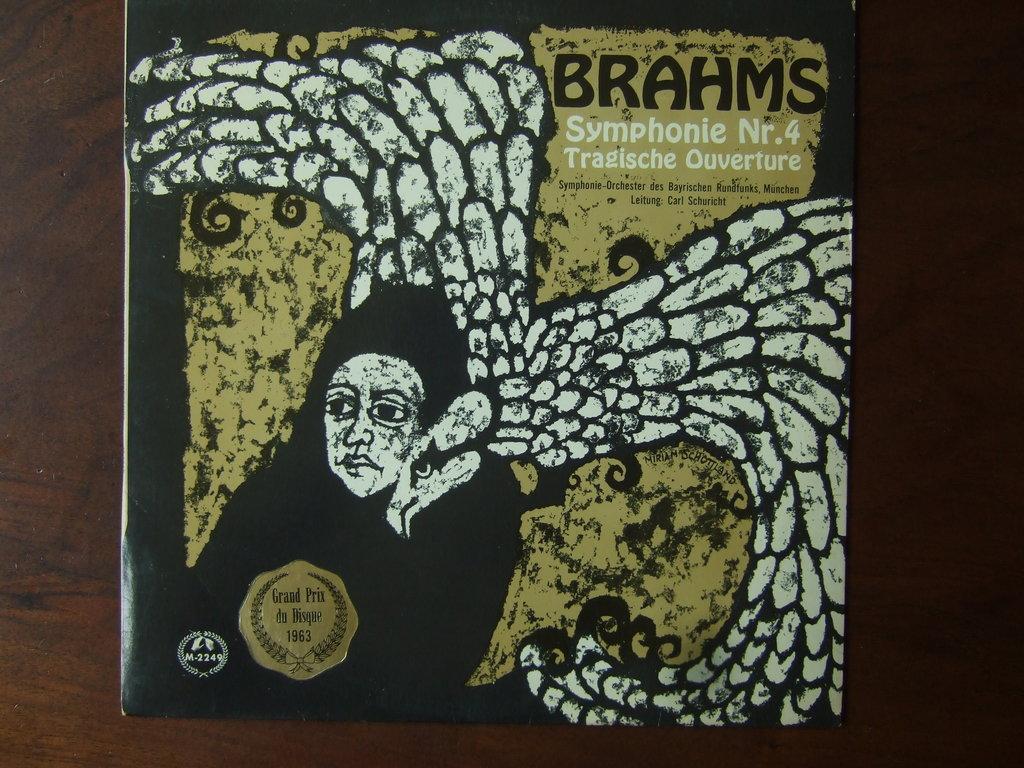Describe this image in one or two sentences. In this image we can see the cover of a book. In this image we can see some pictures and text. In the background of the image there is the wooden surface. 